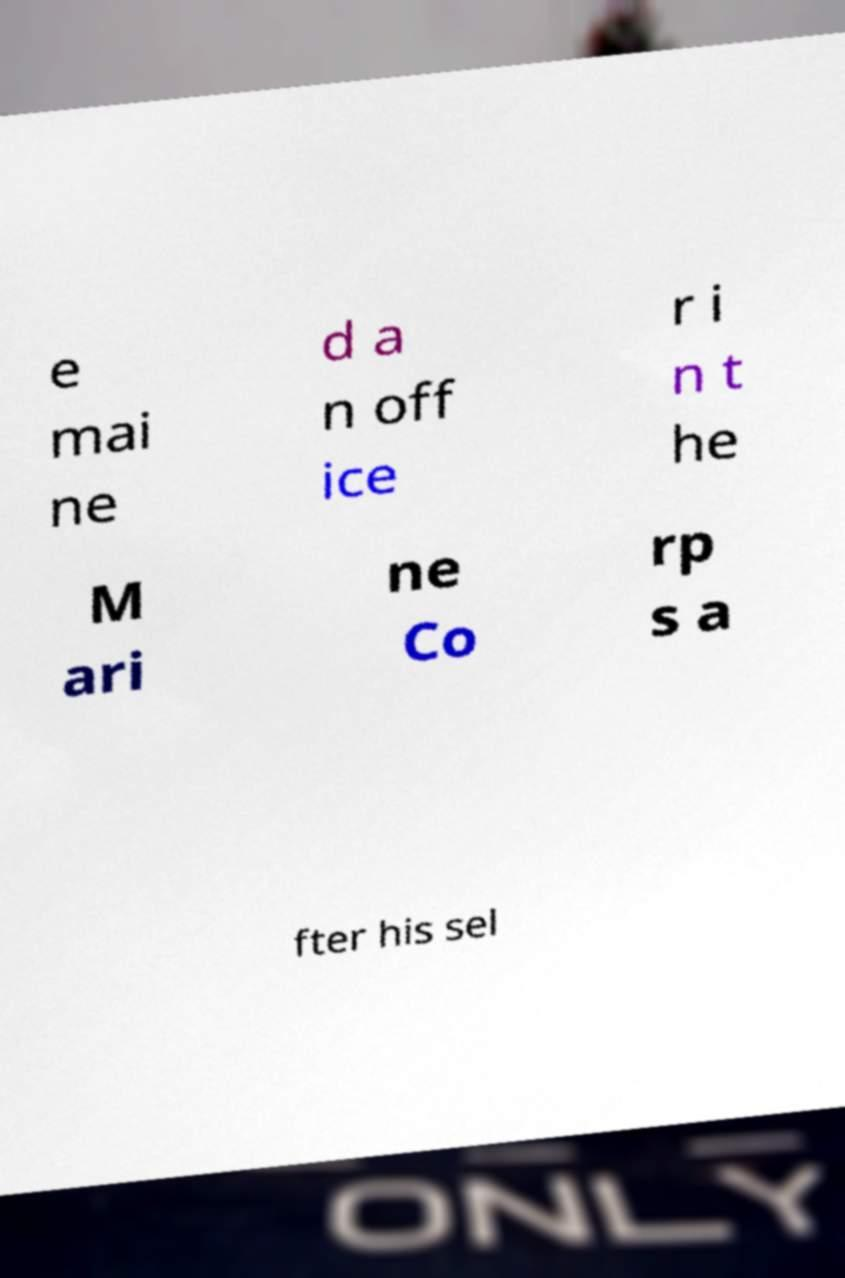Could you assist in decoding the text presented in this image and type it out clearly? e mai ne d a n off ice r i n t he M ari ne Co rp s a fter his sel 